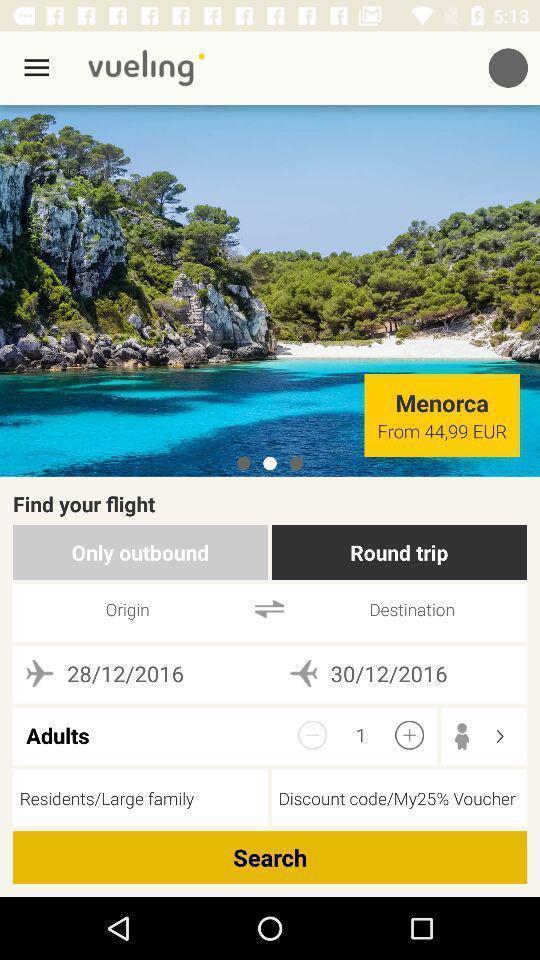Summarize the main components in this picture. Page showing find your flight. 